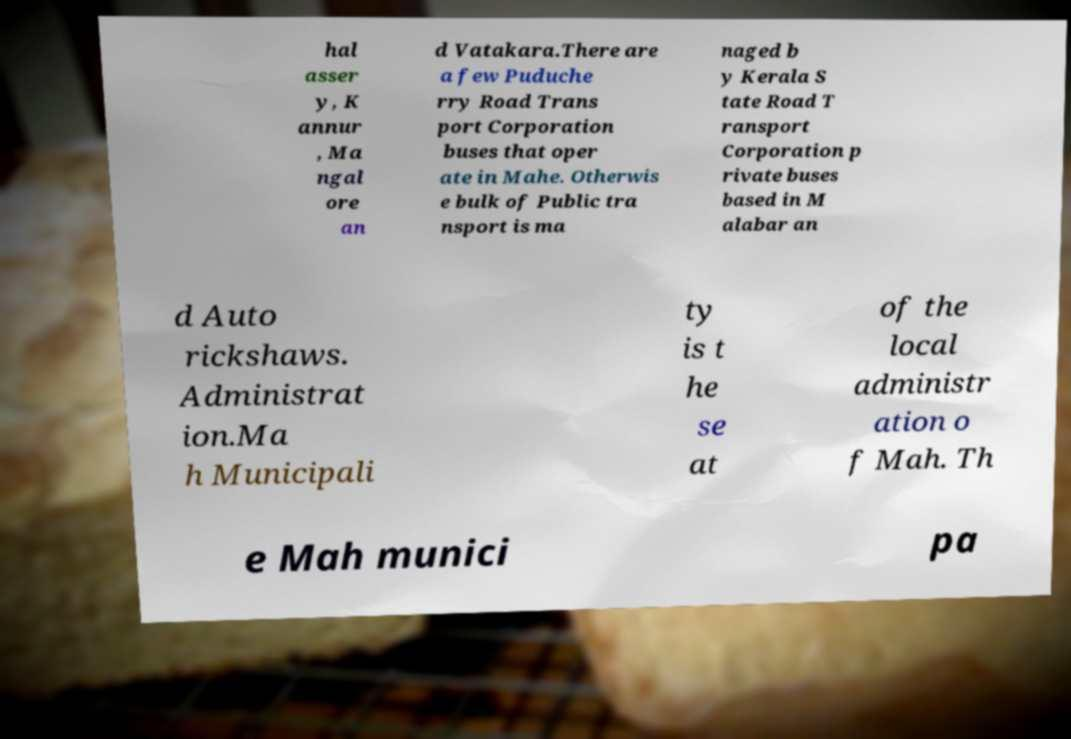Please identify and transcribe the text found in this image. hal asser y, K annur , Ma ngal ore an d Vatakara.There are a few Puduche rry Road Trans port Corporation buses that oper ate in Mahe. Otherwis e bulk of Public tra nsport is ma naged b y Kerala S tate Road T ransport Corporation p rivate buses based in M alabar an d Auto rickshaws. Administrat ion.Ma h Municipali ty is t he se at of the local administr ation o f Mah. Th e Mah munici pa 